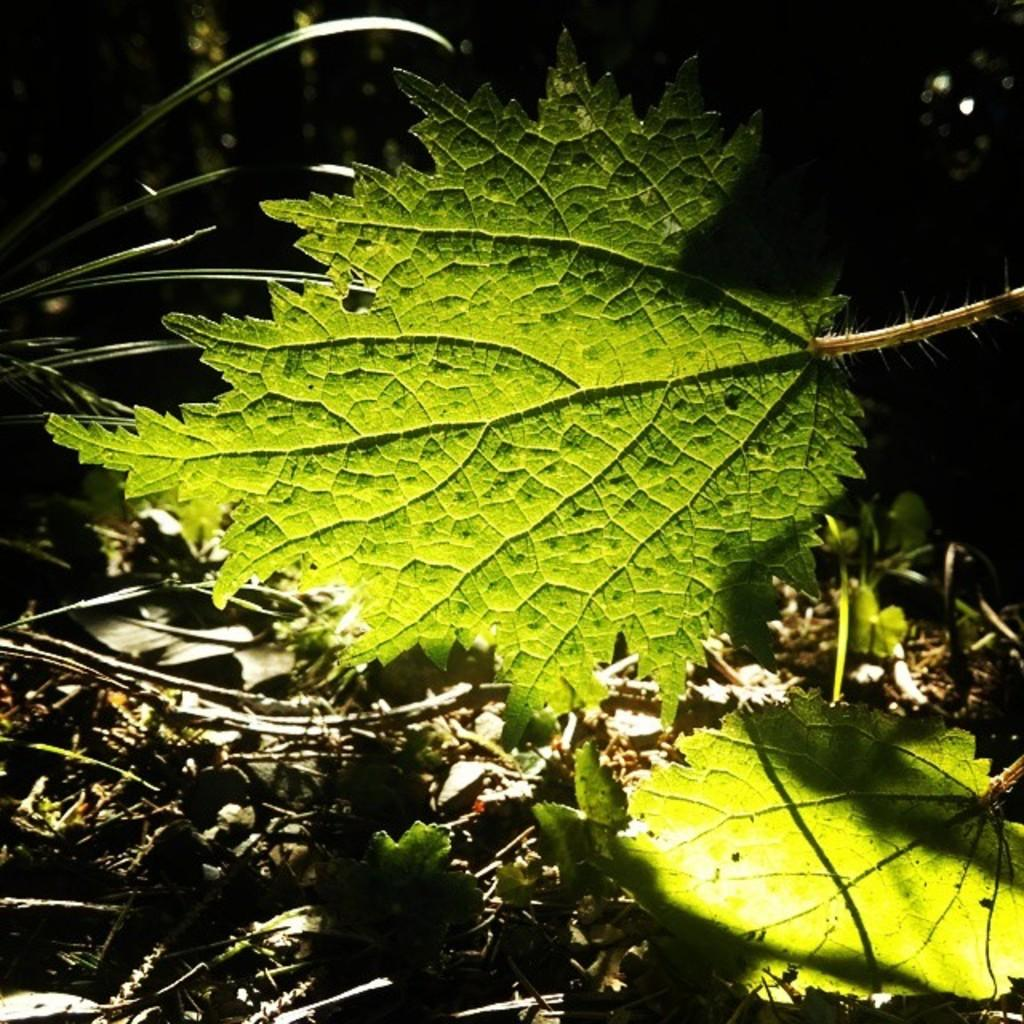What is covering the front of the image? There are leaves in front of the image. What can be found at the bottom of the image? There are dried leaves and branches at the bottom of the image. Can you describe the surface at the bottom of the image? The surface at the bottom of the image is covered with branches. Is there a spark visible in the image? There is no mention of a spark in the provided facts, so it cannot be determined if one is present in the image. 